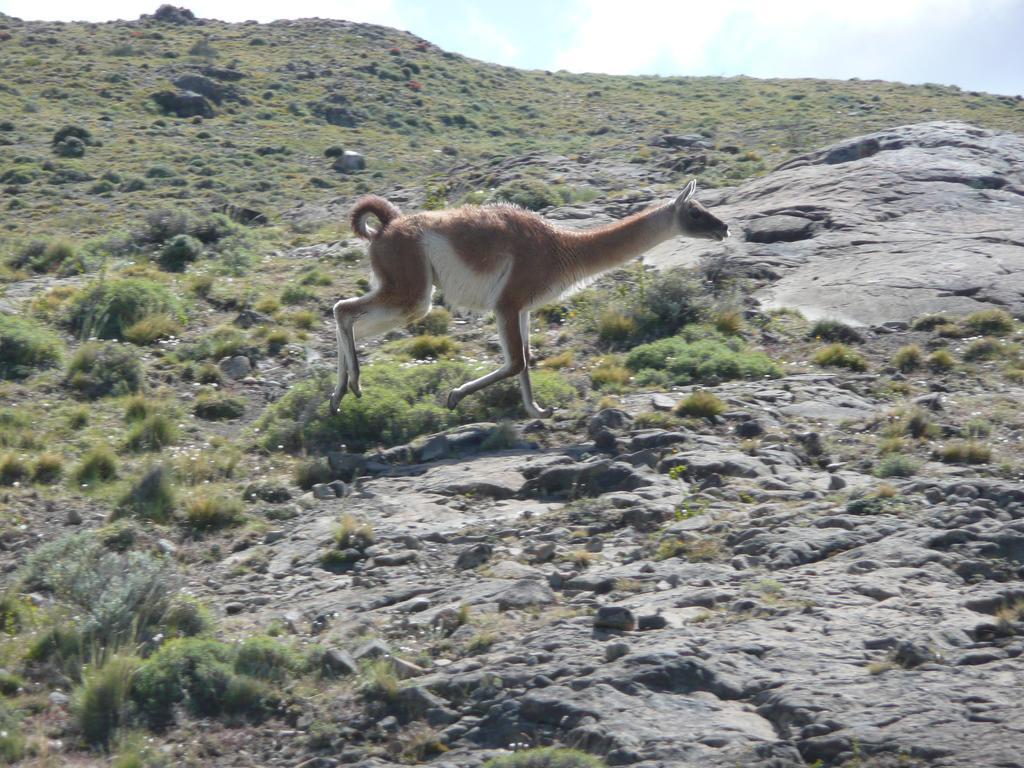Describe this image in one or two sentences. This is the picture of a kangaroo which is on the rocks and around there are some plants and grass. 